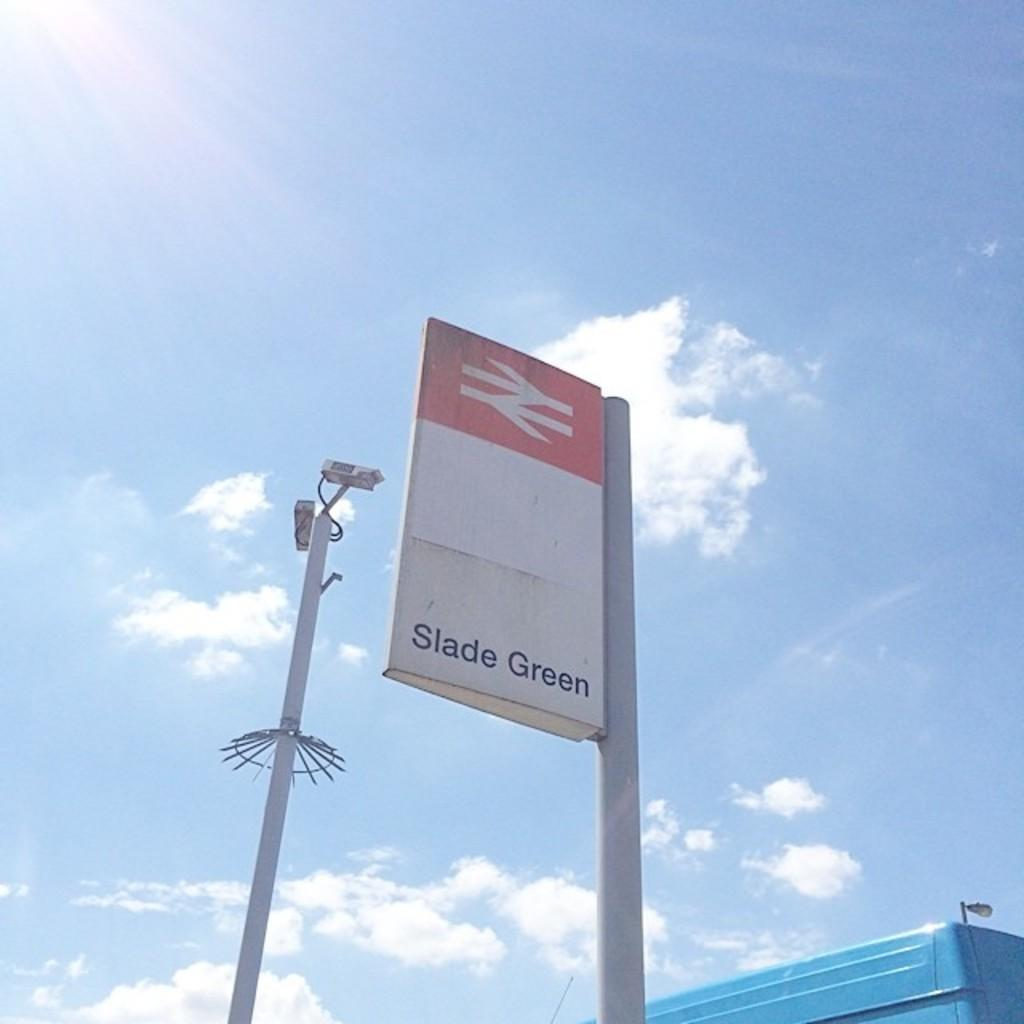Provide a one-sentence caption for the provided image. The weather is sunny and clear and a sign for Slade Green can be seen. 